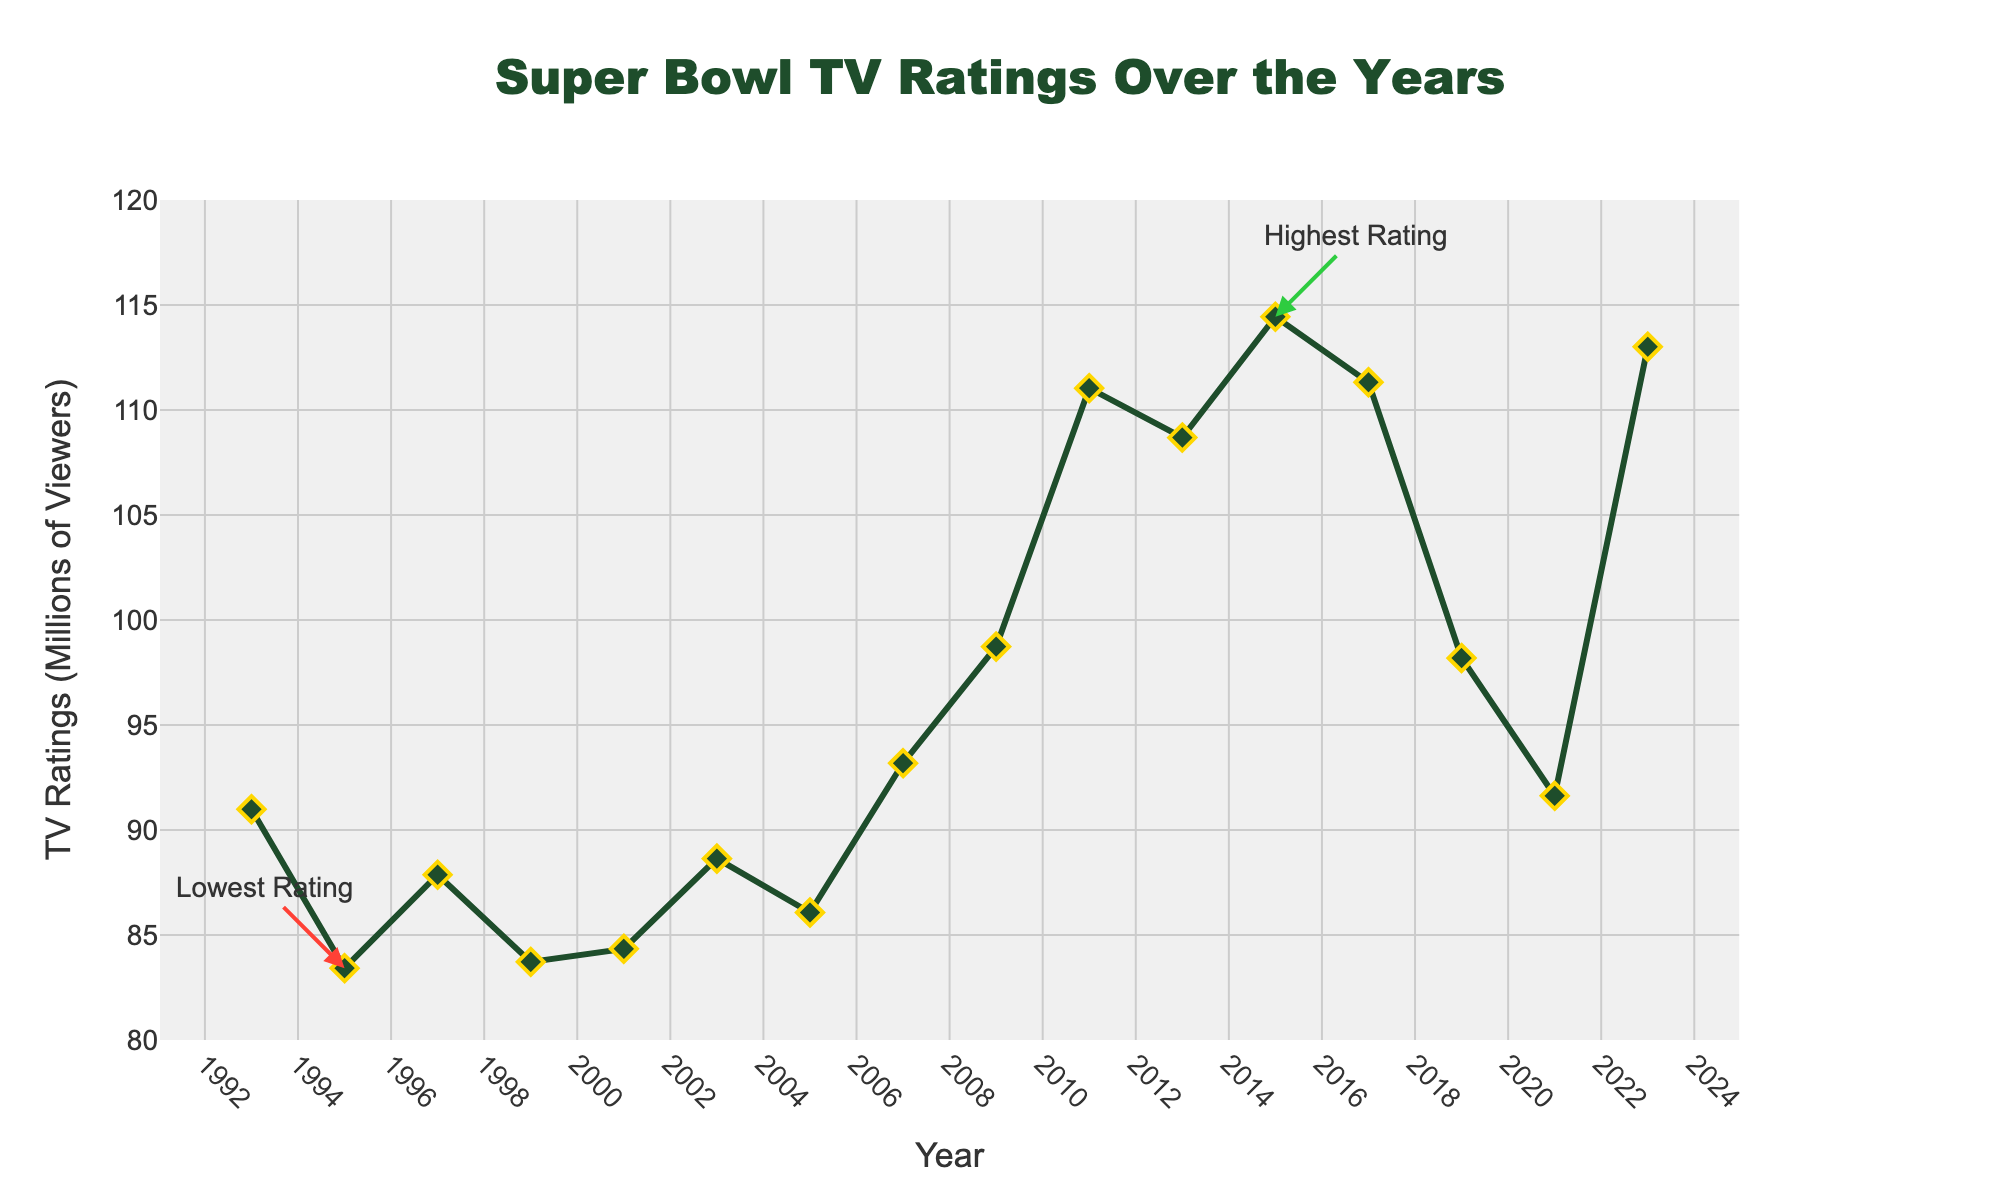What year had the lowest TV rating for the Super Bowl? The lowest TV rating is annotated as "Lowest Rating" in the figure, which points to the year 1995.
Answer: 1995 What year had the highest TV rating for the Super Bowl? The highest TV rating is annotated as "Highest Rating" in the figure, which points to the year 2015.
Answer: 2015 Between 2011 and 2015, was there an increase or decrease in TV ratings for the Super Bowl? Inspecting the figure shows the rating in 2011 was approximately 111 million, and in 2015, it increased to around 114 million.
Answer: Increase Which years had TV ratings above 110 million viewers? The figure shows that TV ratings exceeded 110 million viewers in the years 2011, 2015, and 2017.
Answer: 2011, 2015, 2017 What is the difference in TV ratings between 1993 and 2023? The figure shows around 91 million viewers in 1993 and 113 million viewers in 2023. The difference is 113 - 91 = 22 million.
Answer: 22 million How many years show TV ratings under 90 million viewers? Observing the data points, the years with TV ratings under 90 million are 1995, 1997, 1999, and 2001, totaling four years.
Answer: 4 years Compare the TV ratings between 2007 and 2009. Which year had higher ratings? The rating in 2007 was around 93 million, and it increased to approximately 99 million in 2009. 2009 had higher ratings.
Answer: 2009 What is the range of TV ratings, defined as the difference between the highest and lowest ratings? The highest rating is about 114 million (2015), and the lowest is about 83 million (1995). The range is 114 - 83 = 31 million.
Answer: 31 million What trend in TV ratings is observed from 2003 to 2011? The figure shows a general upward trend in TV ratings from around 89 million in 2003 to approximately 111 million in 2011.
Answer: Upward trend 